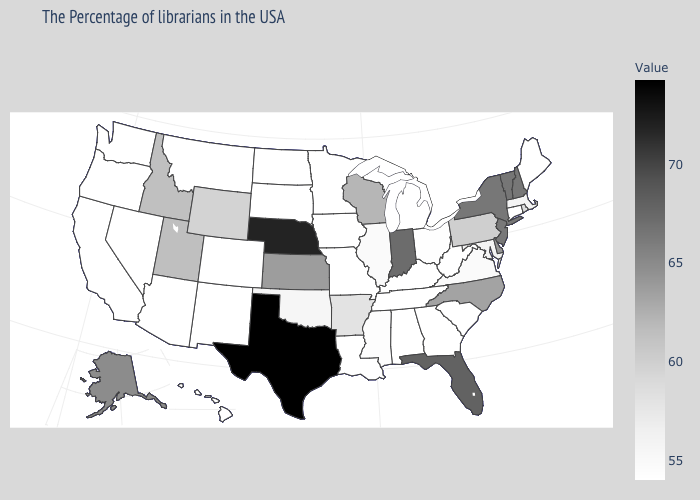Among the states that border Maryland , which have the lowest value?
Write a very short answer. West Virginia. Among the states that border Georgia , which have the highest value?
Answer briefly. Florida. Which states hav the highest value in the South?
Be succinct. Texas. Which states have the lowest value in the USA?
Give a very brief answer. Maine, Connecticut, South Carolina, West Virginia, Georgia, Michigan, Kentucky, Alabama, Tennessee, Louisiana, Missouri, Minnesota, Iowa, South Dakota, North Dakota, Colorado, New Mexico, Montana, Arizona, Nevada, California, Washington, Oregon, Hawaii. Which states have the lowest value in the South?
Keep it brief. South Carolina, West Virginia, Georgia, Kentucky, Alabama, Tennessee, Louisiana. Does Kansas have a higher value than South Carolina?
Be succinct. Yes. Does Tennessee have the lowest value in the USA?
Keep it brief. Yes. Does West Virginia have the lowest value in the South?
Answer briefly. Yes. 